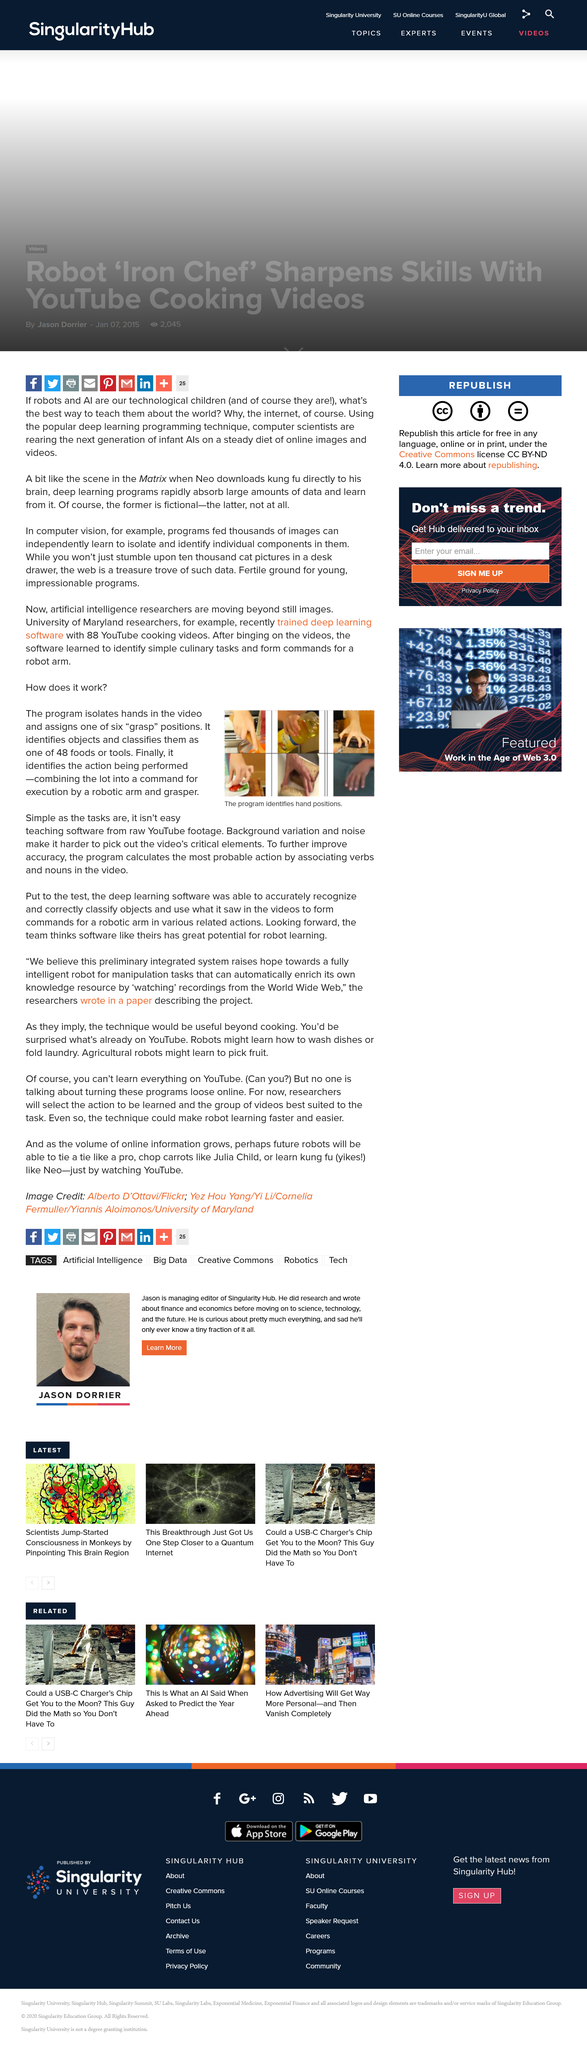Mention a couple of crucial points in this snapshot. The program classifies objects as either one of 48 food items or tools by utilizing a trained neural network with a pre-defined set of features. The program is designed to identify hand positions by analyzing images captured through a webcam or video input. The team believes that the software they have developed has enormous potential for robot learning, as they think highly of it. 